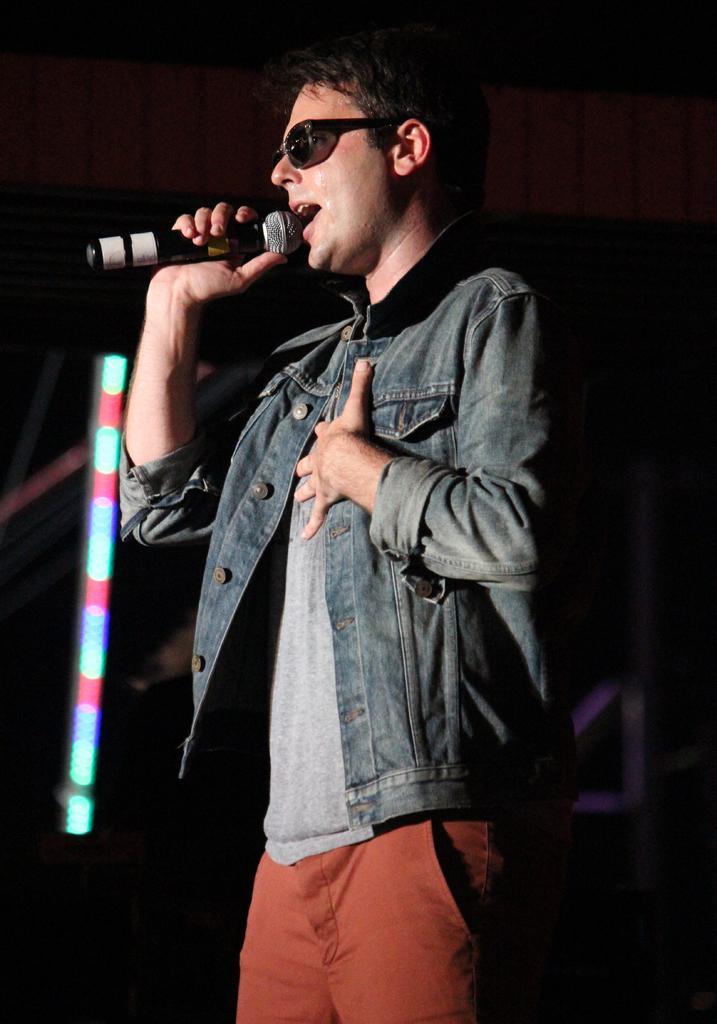Please provide a concise description of this image. In this image one person is holding the mike and singing the song and he is wearing grey t-shirt,orange pant and denim coat and background is dark. 